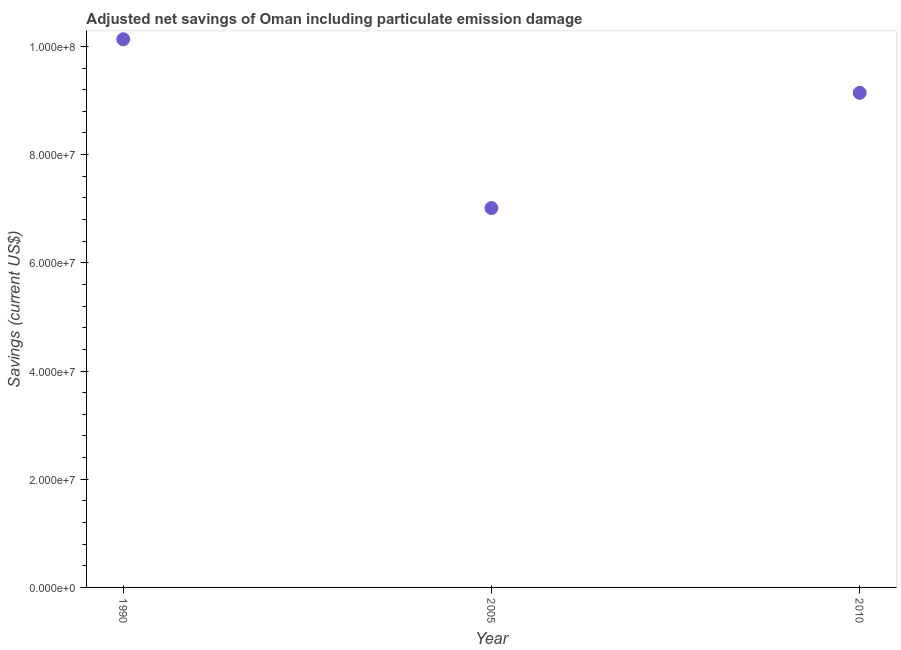What is the adjusted net savings in 1990?
Provide a short and direct response. 1.01e+08. Across all years, what is the maximum adjusted net savings?
Keep it short and to the point. 1.01e+08. Across all years, what is the minimum adjusted net savings?
Provide a short and direct response. 7.01e+07. In which year was the adjusted net savings minimum?
Your response must be concise. 2005. What is the sum of the adjusted net savings?
Your response must be concise. 2.63e+08. What is the difference between the adjusted net savings in 2005 and 2010?
Keep it short and to the point. -2.13e+07. What is the average adjusted net savings per year?
Make the answer very short. 8.76e+07. What is the median adjusted net savings?
Your answer should be compact. 9.14e+07. Do a majority of the years between 2005 and 2010 (inclusive) have adjusted net savings greater than 20000000 US$?
Offer a terse response. Yes. What is the ratio of the adjusted net savings in 1990 to that in 2010?
Give a very brief answer. 1.11. What is the difference between the highest and the second highest adjusted net savings?
Provide a succinct answer. 9.91e+06. What is the difference between the highest and the lowest adjusted net savings?
Keep it short and to the point. 3.12e+07. In how many years, is the adjusted net savings greater than the average adjusted net savings taken over all years?
Give a very brief answer. 2. Does the adjusted net savings monotonically increase over the years?
Provide a short and direct response. No. How many dotlines are there?
Offer a terse response. 1. What is the difference between two consecutive major ticks on the Y-axis?
Your response must be concise. 2.00e+07. Does the graph contain any zero values?
Keep it short and to the point. No. Does the graph contain grids?
Offer a very short reply. No. What is the title of the graph?
Ensure brevity in your answer.  Adjusted net savings of Oman including particulate emission damage. What is the label or title of the X-axis?
Provide a short and direct response. Year. What is the label or title of the Y-axis?
Provide a short and direct response. Savings (current US$). What is the Savings (current US$) in 1990?
Make the answer very short. 1.01e+08. What is the Savings (current US$) in 2005?
Make the answer very short. 7.01e+07. What is the Savings (current US$) in 2010?
Offer a terse response. 9.14e+07. What is the difference between the Savings (current US$) in 1990 and 2005?
Offer a very short reply. 3.12e+07. What is the difference between the Savings (current US$) in 1990 and 2010?
Give a very brief answer. 9.91e+06. What is the difference between the Savings (current US$) in 2005 and 2010?
Provide a succinct answer. -2.13e+07. What is the ratio of the Savings (current US$) in 1990 to that in 2005?
Your response must be concise. 1.45. What is the ratio of the Savings (current US$) in 1990 to that in 2010?
Give a very brief answer. 1.11. What is the ratio of the Savings (current US$) in 2005 to that in 2010?
Give a very brief answer. 0.77. 